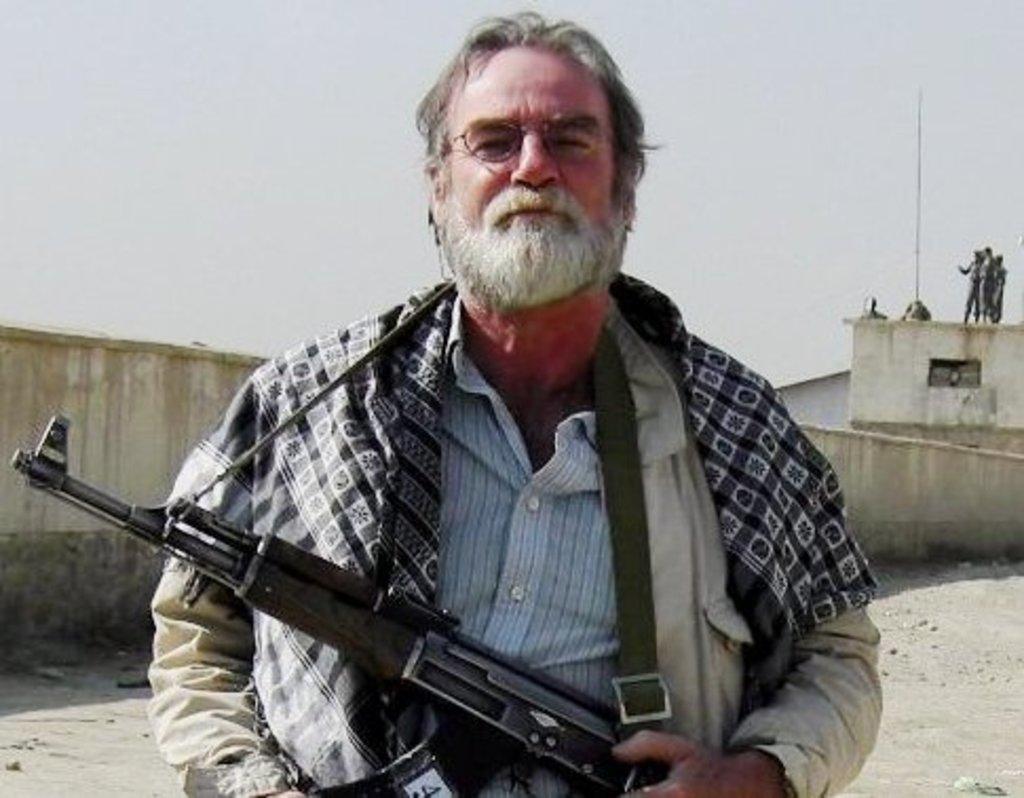In one or two sentences, can you explain what this image depicts? This is the picture of a place where we have a person wearing spectacles and holding the gun, behind there are some other people on the roof and a wall. 